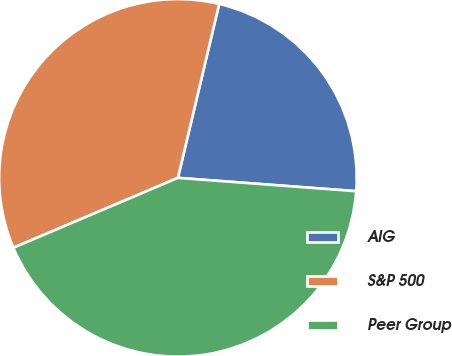<chart> <loc_0><loc_0><loc_500><loc_500><pie_chart><fcel>AIG<fcel>S&P 500<fcel>Peer Group<nl><fcel>22.48%<fcel>35.1%<fcel>42.42%<nl></chart> 